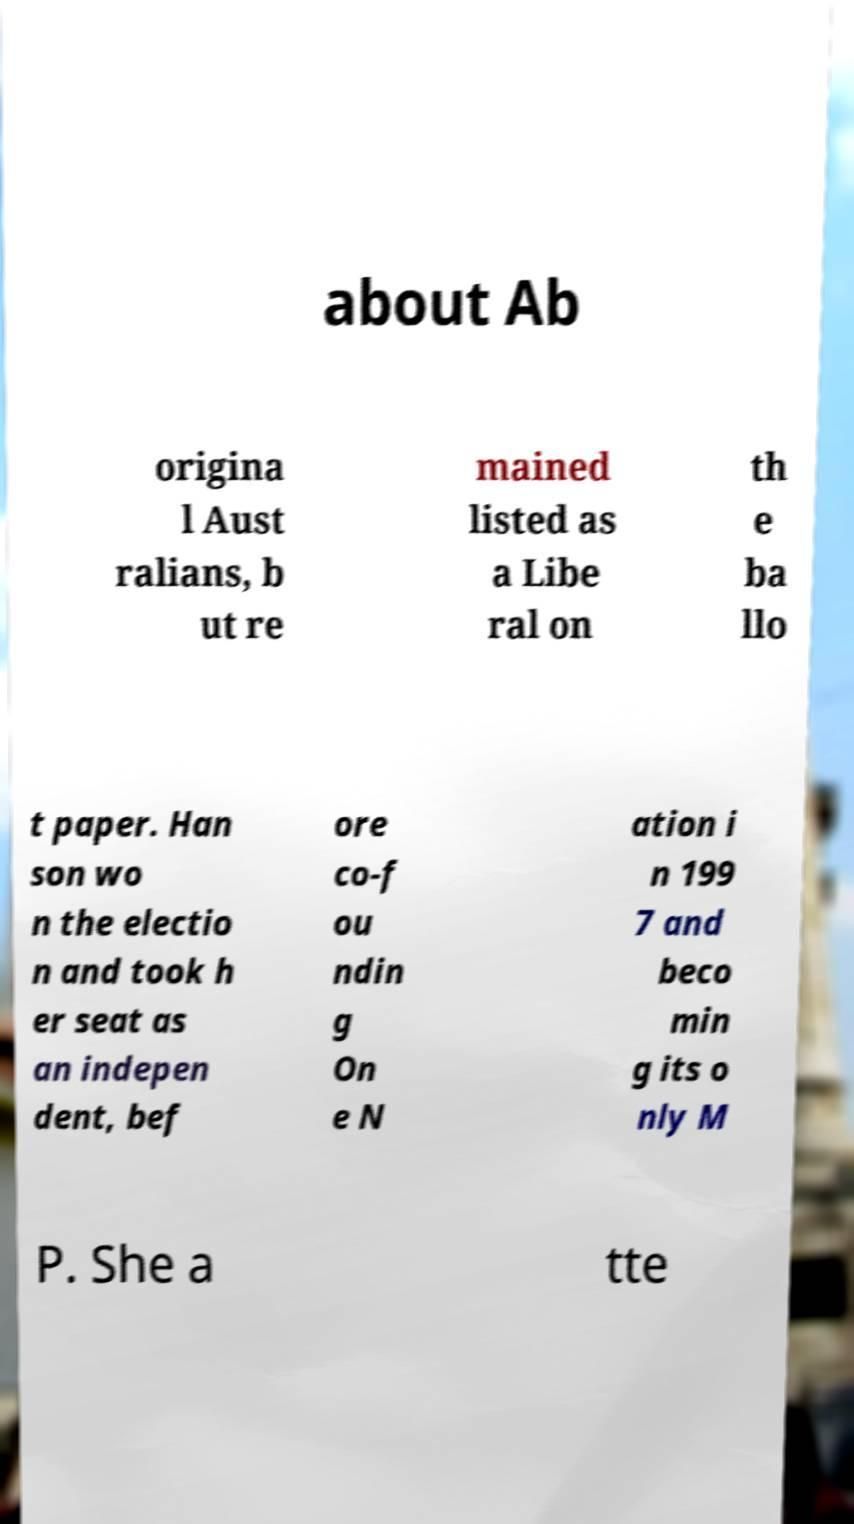I need the written content from this picture converted into text. Can you do that? about Ab origina l Aust ralians, b ut re mained listed as a Libe ral on th e ba llo t paper. Han son wo n the electio n and took h er seat as an indepen dent, bef ore co-f ou ndin g On e N ation i n 199 7 and beco min g its o nly M P. She a tte 